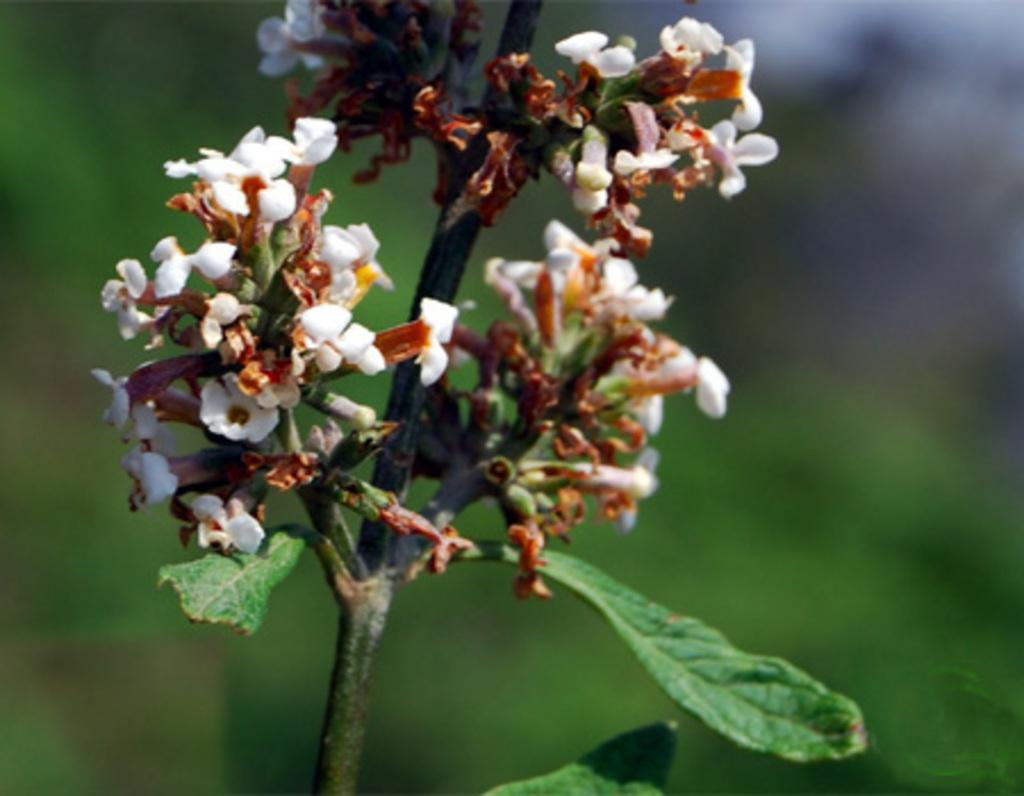What type of plant life is present in the image? There are flowers in the image. Where are the flowers located? The flowers are on a branch. What other plant elements can be seen in the image? There are leaves in the image. How would you describe the background of the image? The background of the image is blurred. What type of brass object is hanging from the branch in the image? There is no brass object present in the image; it only features flowers and leaves. 